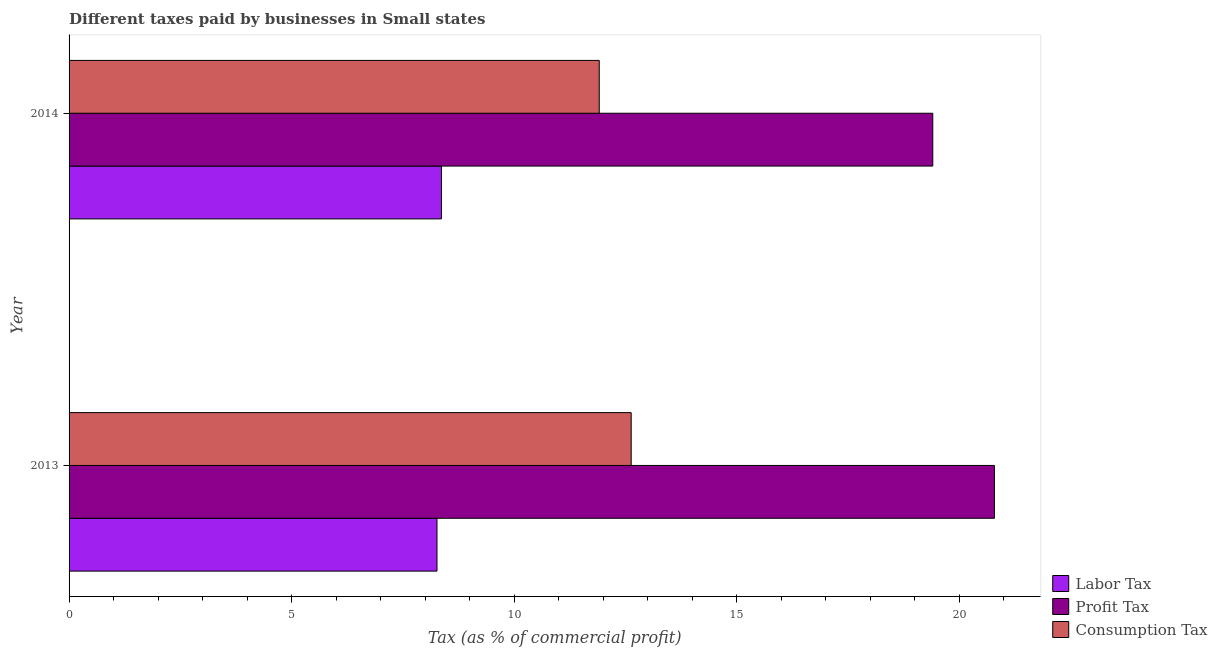How many different coloured bars are there?
Your answer should be compact. 3. Are the number of bars on each tick of the Y-axis equal?
Give a very brief answer. Yes. What is the label of the 1st group of bars from the top?
Provide a short and direct response. 2014. In how many cases, is the number of bars for a given year not equal to the number of legend labels?
Your answer should be very brief. 0. What is the percentage of profit tax in 2014?
Keep it short and to the point. 19.4. Across all years, what is the maximum percentage of labor tax?
Make the answer very short. 8.37. Across all years, what is the minimum percentage of profit tax?
Ensure brevity in your answer.  19.4. What is the total percentage of profit tax in the graph?
Offer a terse response. 40.19. What is the difference between the percentage of labor tax in 2013 and that in 2014?
Keep it short and to the point. -0.1. What is the difference between the percentage of profit tax in 2013 and the percentage of labor tax in 2014?
Your answer should be very brief. 12.42. What is the average percentage of labor tax per year?
Give a very brief answer. 8.31. In the year 2013, what is the difference between the percentage of labor tax and percentage of consumption tax?
Your answer should be compact. -4.36. In how many years, is the percentage of profit tax greater than 17 %?
Your answer should be very brief. 2. What is the ratio of the percentage of labor tax in 2013 to that in 2014?
Give a very brief answer. 0.99. Is the difference between the percentage of labor tax in 2013 and 2014 greater than the difference between the percentage of consumption tax in 2013 and 2014?
Provide a short and direct response. No. In how many years, is the percentage of profit tax greater than the average percentage of profit tax taken over all years?
Your answer should be compact. 1. What does the 1st bar from the top in 2014 represents?
Provide a short and direct response. Consumption Tax. What does the 1st bar from the bottom in 2013 represents?
Offer a terse response. Labor Tax. Is it the case that in every year, the sum of the percentage of labor tax and percentage of profit tax is greater than the percentage of consumption tax?
Ensure brevity in your answer.  Yes. How many bars are there?
Ensure brevity in your answer.  6. Are all the bars in the graph horizontal?
Make the answer very short. Yes. How many years are there in the graph?
Provide a succinct answer. 2. What is the difference between two consecutive major ticks on the X-axis?
Offer a terse response. 5. Are the values on the major ticks of X-axis written in scientific E-notation?
Offer a terse response. No. Does the graph contain any zero values?
Make the answer very short. No. How many legend labels are there?
Give a very brief answer. 3. What is the title of the graph?
Make the answer very short. Different taxes paid by businesses in Small states. Does "Liquid fuel" appear as one of the legend labels in the graph?
Provide a short and direct response. No. What is the label or title of the X-axis?
Provide a short and direct response. Tax (as % of commercial profit). What is the Tax (as % of commercial profit) of Labor Tax in 2013?
Offer a very short reply. 8.27. What is the Tax (as % of commercial profit) of Profit Tax in 2013?
Ensure brevity in your answer.  20.79. What is the Tax (as % of commercial profit) of Consumption Tax in 2013?
Ensure brevity in your answer.  12.63. What is the Tax (as % of commercial profit) in Labor Tax in 2014?
Provide a short and direct response. 8.37. What is the Tax (as % of commercial profit) in Profit Tax in 2014?
Make the answer very short. 19.4. What is the Tax (as % of commercial profit) of Consumption Tax in 2014?
Your answer should be very brief. 11.91. Across all years, what is the maximum Tax (as % of commercial profit) in Labor Tax?
Offer a very short reply. 8.37. Across all years, what is the maximum Tax (as % of commercial profit) in Profit Tax?
Make the answer very short. 20.79. Across all years, what is the maximum Tax (as % of commercial profit) in Consumption Tax?
Your response must be concise. 12.63. Across all years, what is the minimum Tax (as % of commercial profit) of Labor Tax?
Provide a succinct answer. 8.27. Across all years, what is the minimum Tax (as % of commercial profit) of Profit Tax?
Your response must be concise. 19.4. Across all years, what is the minimum Tax (as % of commercial profit) in Consumption Tax?
Make the answer very short. 11.91. What is the total Tax (as % of commercial profit) of Labor Tax in the graph?
Your answer should be compact. 16.63. What is the total Tax (as % of commercial profit) of Profit Tax in the graph?
Provide a succinct answer. 40.19. What is the total Tax (as % of commercial profit) in Consumption Tax in the graph?
Make the answer very short. 24.54. What is the difference between the Tax (as % of commercial profit) in Profit Tax in 2013 and that in 2014?
Ensure brevity in your answer.  1.39. What is the difference between the Tax (as % of commercial profit) of Consumption Tax in 2013 and that in 2014?
Give a very brief answer. 0.72. What is the difference between the Tax (as % of commercial profit) in Labor Tax in 2013 and the Tax (as % of commercial profit) in Profit Tax in 2014?
Offer a very short reply. -11.14. What is the difference between the Tax (as % of commercial profit) in Labor Tax in 2013 and the Tax (as % of commercial profit) in Consumption Tax in 2014?
Offer a very short reply. -3.65. What is the difference between the Tax (as % of commercial profit) in Profit Tax in 2013 and the Tax (as % of commercial profit) in Consumption Tax in 2014?
Keep it short and to the point. 8.88. What is the average Tax (as % of commercial profit) in Labor Tax per year?
Your answer should be very brief. 8.31. What is the average Tax (as % of commercial profit) of Profit Tax per year?
Ensure brevity in your answer.  20.09. What is the average Tax (as % of commercial profit) of Consumption Tax per year?
Offer a very short reply. 12.27. In the year 2013, what is the difference between the Tax (as % of commercial profit) of Labor Tax and Tax (as % of commercial profit) of Profit Tax?
Give a very brief answer. -12.52. In the year 2013, what is the difference between the Tax (as % of commercial profit) in Labor Tax and Tax (as % of commercial profit) in Consumption Tax?
Your answer should be very brief. -4.36. In the year 2013, what is the difference between the Tax (as % of commercial profit) in Profit Tax and Tax (as % of commercial profit) in Consumption Tax?
Offer a terse response. 8.16. In the year 2014, what is the difference between the Tax (as % of commercial profit) in Labor Tax and Tax (as % of commercial profit) in Profit Tax?
Offer a very short reply. -11.04. In the year 2014, what is the difference between the Tax (as % of commercial profit) of Labor Tax and Tax (as % of commercial profit) of Consumption Tax?
Offer a terse response. -3.54. In the year 2014, what is the difference between the Tax (as % of commercial profit) in Profit Tax and Tax (as % of commercial profit) in Consumption Tax?
Ensure brevity in your answer.  7.49. What is the ratio of the Tax (as % of commercial profit) in Profit Tax in 2013 to that in 2014?
Offer a terse response. 1.07. What is the ratio of the Tax (as % of commercial profit) of Consumption Tax in 2013 to that in 2014?
Your answer should be compact. 1.06. What is the difference between the highest and the second highest Tax (as % of commercial profit) in Labor Tax?
Your answer should be compact. 0.1. What is the difference between the highest and the second highest Tax (as % of commercial profit) of Profit Tax?
Your answer should be compact. 1.39. What is the difference between the highest and the second highest Tax (as % of commercial profit) of Consumption Tax?
Give a very brief answer. 0.72. What is the difference between the highest and the lowest Tax (as % of commercial profit) of Profit Tax?
Provide a succinct answer. 1.39. What is the difference between the highest and the lowest Tax (as % of commercial profit) in Consumption Tax?
Your answer should be compact. 0.72. 